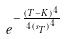Convert formula to latex. <formula><loc_0><loc_0><loc_500><loc_500>e ^ { - \frac { ( T - K ) ^ { 4 } } { 4 { ( s _ { T } ) } ^ { 4 } } }</formula> 